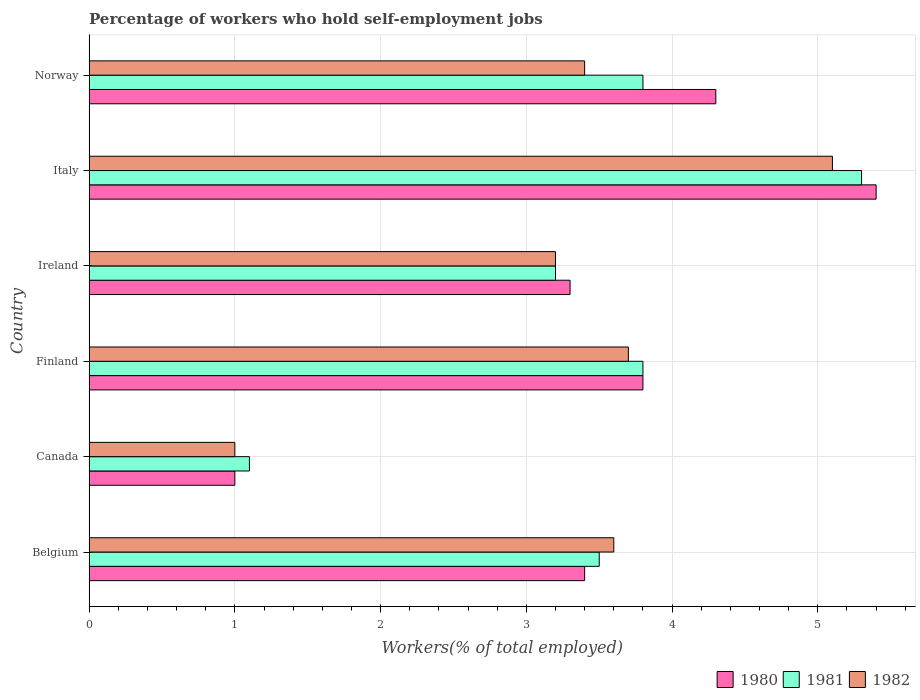How many groups of bars are there?
Keep it short and to the point. 6. Are the number of bars on each tick of the Y-axis equal?
Offer a terse response. Yes. How many bars are there on the 5th tick from the top?
Ensure brevity in your answer.  3. How many bars are there on the 1st tick from the bottom?
Make the answer very short. 3. In how many cases, is the number of bars for a given country not equal to the number of legend labels?
Keep it short and to the point. 0. What is the percentage of self-employed workers in 1982 in Ireland?
Provide a short and direct response. 3.2. Across all countries, what is the maximum percentage of self-employed workers in 1982?
Keep it short and to the point. 5.1. Across all countries, what is the minimum percentage of self-employed workers in 1980?
Your answer should be compact. 1. In which country was the percentage of self-employed workers in 1981 maximum?
Provide a short and direct response. Italy. In which country was the percentage of self-employed workers in 1980 minimum?
Ensure brevity in your answer.  Canada. What is the total percentage of self-employed workers in 1982 in the graph?
Your answer should be compact. 20. What is the difference between the percentage of self-employed workers in 1980 in Finland and that in Norway?
Provide a short and direct response. -0.5. What is the difference between the percentage of self-employed workers in 1982 in Norway and the percentage of self-employed workers in 1980 in Finland?
Give a very brief answer. -0.4. What is the average percentage of self-employed workers in 1981 per country?
Offer a very short reply. 3.45. What is the difference between the percentage of self-employed workers in 1982 and percentage of self-employed workers in 1980 in Norway?
Ensure brevity in your answer.  -0.9. What is the ratio of the percentage of self-employed workers in 1980 in Finland to that in Italy?
Ensure brevity in your answer.  0.7. What is the difference between the highest and the second highest percentage of self-employed workers in 1981?
Provide a short and direct response. 1.5. What is the difference between the highest and the lowest percentage of self-employed workers in 1980?
Your answer should be very brief. 4.4. Is the sum of the percentage of self-employed workers in 1982 in Canada and Ireland greater than the maximum percentage of self-employed workers in 1980 across all countries?
Your answer should be compact. No. What does the 1st bar from the top in Belgium represents?
Provide a succinct answer. 1982. What does the 1st bar from the bottom in Italy represents?
Your response must be concise. 1980. Is it the case that in every country, the sum of the percentage of self-employed workers in 1980 and percentage of self-employed workers in 1982 is greater than the percentage of self-employed workers in 1981?
Offer a terse response. Yes. Are all the bars in the graph horizontal?
Keep it short and to the point. Yes. How many countries are there in the graph?
Make the answer very short. 6. Are the values on the major ticks of X-axis written in scientific E-notation?
Provide a short and direct response. No. How many legend labels are there?
Keep it short and to the point. 3. What is the title of the graph?
Your answer should be compact. Percentage of workers who hold self-employment jobs. Does "1976" appear as one of the legend labels in the graph?
Make the answer very short. No. What is the label or title of the X-axis?
Offer a terse response. Workers(% of total employed). What is the label or title of the Y-axis?
Make the answer very short. Country. What is the Workers(% of total employed) of 1980 in Belgium?
Give a very brief answer. 3.4. What is the Workers(% of total employed) of 1981 in Belgium?
Your response must be concise. 3.5. What is the Workers(% of total employed) of 1982 in Belgium?
Your answer should be very brief. 3.6. What is the Workers(% of total employed) in 1981 in Canada?
Provide a succinct answer. 1.1. What is the Workers(% of total employed) in 1980 in Finland?
Make the answer very short. 3.8. What is the Workers(% of total employed) of 1981 in Finland?
Offer a very short reply. 3.8. What is the Workers(% of total employed) of 1982 in Finland?
Make the answer very short. 3.7. What is the Workers(% of total employed) in 1980 in Ireland?
Give a very brief answer. 3.3. What is the Workers(% of total employed) in 1981 in Ireland?
Your response must be concise. 3.2. What is the Workers(% of total employed) in 1982 in Ireland?
Ensure brevity in your answer.  3.2. What is the Workers(% of total employed) in 1980 in Italy?
Give a very brief answer. 5.4. What is the Workers(% of total employed) of 1981 in Italy?
Make the answer very short. 5.3. What is the Workers(% of total employed) in 1982 in Italy?
Your answer should be compact. 5.1. What is the Workers(% of total employed) in 1980 in Norway?
Give a very brief answer. 4.3. What is the Workers(% of total employed) of 1981 in Norway?
Your response must be concise. 3.8. What is the Workers(% of total employed) of 1982 in Norway?
Ensure brevity in your answer.  3.4. Across all countries, what is the maximum Workers(% of total employed) in 1980?
Offer a very short reply. 5.4. Across all countries, what is the maximum Workers(% of total employed) in 1981?
Your answer should be compact. 5.3. Across all countries, what is the maximum Workers(% of total employed) in 1982?
Keep it short and to the point. 5.1. Across all countries, what is the minimum Workers(% of total employed) of 1981?
Offer a very short reply. 1.1. What is the total Workers(% of total employed) of 1980 in the graph?
Your response must be concise. 21.2. What is the total Workers(% of total employed) in 1981 in the graph?
Offer a very short reply. 20.7. What is the difference between the Workers(% of total employed) of 1980 in Belgium and that in Canada?
Provide a short and direct response. 2.4. What is the difference between the Workers(% of total employed) of 1982 in Belgium and that in Canada?
Give a very brief answer. 2.6. What is the difference between the Workers(% of total employed) in 1980 in Belgium and that in Ireland?
Offer a very short reply. 0.1. What is the difference between the Workers(% of total employed) in 1981 in Belgium and that in Ireland?
Ensure brevity in your answer.  0.3. What is the difference between the Workers(% of total employed) in 1982 in Belgium and that in Ireland?
Ensure brevity in your answer.  0.4. What is the difference between the Workers(% of total employed) of 1981 in Belgium and that in Italy?
Keep it short and to the point. -1.8. What is the difference between the Workers(% of total employed) in 1982 in Belgium and that in Italy?
Your response must be concise. -1.5. What is the difference between the Workers(% of total employed) in 1980 in Belgium and that in Norway?
Keep it short and to the point. -0.9. What is the difference between the Workers(% of total employed) of 1980 in Canada and that in Finland?
Make the answer very short. -2.8. What is the difference between the Workers(% of total employed) of 1981 in Canada and that in Finland?
Your response must be concise. -2.7. What is the difference between the Workers(% of total employed) of 1980 in Canada and that in Ireland?
Give a very brief answer. -2.3. What is the difference between the Workers(% of total employed) of 1982 in Canada and that in Ireland?
Offer a terse response. -2.2. What is the difference between the Workers(% of total employed) in 1980 in Canada and that in Italy?
Your response must be concise. -4.4. What is the difference between the Workers(% of total employed) of 1981 in Canada and that in Italy?
Keep it short and to the point. -4.2. What is the difference between the Workers(% of total employed) in 1981 in Canada and that in Norway?
Offer a terse response. -2.7. What is the difference between the Workers(% of total employed) of 1982 in Canada and that in Norway?
Provide a short and direct response. -2.4. What is the difference between the Workers(% of total employed) of 1980 in Finland and that in Italy?
Provide a short and direct response. -1.6. What is the difference between the Workers(% of total employed) of 1981 in Finland and that in Italy?
Offer a terse response. -1.5. What is the difference between the Workers(% of total employed) of 1982 in Finland and that in Italy?
Your answer should be compact. -1.4. What is the difference between the Workers(% of total employed) of 1981 in Ireland and that in Norway?
Your response must be concise. -0.6. What is the difference between the Workers(% of total employed) of 1981 in Italy and that in Norway?
Provide a short and direct response. 1.5. What is the difference between the Workers(% of total employed) of 1980 in Belgium and the Workers(% of total employed) of 1981 in Finland?
Your answer should be very brief. -0.4. What is the difference between the Workers(% of total employed) in 1981 in Belgium and the Workers(% of total employed) in 1982 in Ireland?
Offer a terse response. 0.3. What is the difference between the Workers(% of total employed) of 1981 in Belgium and the Workers(% of total employed) of 1982 in Italy?
Provide a succinct answer. -1.6. What is the difference between the Workers(% of total employed) in 1980 in Belgium and the Workers(% of total employed) in 1982 in Norway?
Offer a very short reply. 0. What is the difference between the Workers(% of total employed) in 1981 in Belgium and the Workers(% of total employed) in 1982 in Norway?
Provide a short and direct response. 0.1. What is the difference between the Workers(% of total employed) in 1981 in Canada and the Workers(% of total employed) in 1982 in Ireland?
Keep it short and to the point. -2.1. What is the difference between the Workers(% of total employed) of 1980 in Canada and the Workers(% of total employed) of 1981 in Italy?
Your response must be concise. -4.3. What is the difference between the Workers(% of total employed) of 1980 in Canada and the Workers(% of total employed) of 1982 in Italy?
Make the answer very short. -4.1. What is the difference between the Workers(% of total employed) in 1981 in Canada and the Workers(% of total employed) in 1982 in Italy?
Keep it short and to the point. -4. What is the difference between the Workers(% of total employed) of 1980 in Canada and the Workers(% of total employed) of 1982 in Norway?
Your response must be concise. -2.4. What is the difference between the Workers(% of total employed) in 1981 in Canada and the Workers(% of total employed) in 1982 in Norway?
Offer a very short reply. -2.3. What is the difference between the Workers(% of total employed) of 1981 in Finland and the Workers(% of total employed) of 1982 in Ireland?
Offer a terse response. 0.6. What is the difference between the Workers(% of total employed) of 1980 in Finland and the Workers(% of total employed) of 1982 in Italy?
Make the answer very short. -1.3. What is the difference between the Workers(% of total employed) of 1980 in Finland and the Workers(% of total employed) of 1982 in Norway?
Your answer should be very brief. 0.4. What is the difference between the Workers(% of total employed) of 1980 in Ireland and the Workers(% of total employed) of 1981 in Italy?
Provide a succinct answer. -2. What is the difference between the Workers(% of total employed) of 1980 in Ireland and the Workers(% of total employed) of 1982 in Italy?
Offer a very short reply. -1.8. What is the difference between the Workers(% of total employed) in 1980 in Italy and the Workers(% of total employed) in 1981 in Norway?
Provide a short and direct response. 1.6. What is the difference between the Workers(% of total employed) of 1980 in Italy and the Workers(% of total employed) of 1982 in Norway?
Give a very brief answer. 2. What is the difference between the Workers(% of total employed) of 1981 in Italy and the Workers(% of total employed) of 1982 in Norway?
Your response must be concise. 1.9. What is the average Workers(% of total employed) of 1980 per country?
Your answer should be very brief. 3.53. What is the average Workers(% of total employed) of 1981 per country?
Your response must be concise. 3.45. What is the difference between the Workers(% of total employed) in 1980 and Workers(% of total employed) in 1981 in Belgium?
Provide a succinct answer. -0.1. What is the difference between the Workers(% of total employed) in 1980 and Workers(% of total employed) in 1982 in Belgium?
Your answer should be compact. -0.2. What is the difference between the Workers(% of total employed) in 1980 and Workers(% of total employed) in 1981 in Canada?
Your response must be concise. -0.1. What is the difference between the Workers(% of total employed) of 1980 and Workers(% of total employed) of 1982 in Canada?
Your answer should be compact. 0. What is the difference between the Workers(% of total employed) of 1981 and Workers(% of total employed) of 1982 in Canada?
Make the answer very short. 0.1. What is the difference between the Workers(% of total employed) in 1980 and Workers(% of total employed) in 1981 in Finland?
Your response must be concise. 0. What is the difference between the Workers(% of total employed) of 1980 and Workers(% of total employed) of 1982 in Finland?
Make the answer very short. 0.1. What is the difference between the Workers(% of total employed) of 1981 and Workers(% of total employed) of 1982 in Finland?
Make the answer very short. 0.1. What is the difference between the Workers(% of total employed) in 1980 and Workers(% of total employed) in 1981 in Ireland?
Provide a succinct answer. 0.1. What is the difference between the Workers(% of total employed) in 1980 and Workers(% of total employed) in 1982 in Ireland?
Make the answer very short. 0.1. What is the difference between the Workers(% of total employed) in 1980 and Workers(% of total employed) in 1981 in Italy?
Offer a very short reply. 0.1. What is the difference between the Workers(% of total employed) in 1980 and Workers(% of total employed) in 1982 in Italy?
Ensure brevity in your answer.  0.3. What is the difference between the Workers(% of total employed) of 1981 and Workers(% of total employed) of 1982 in Italy?
Ensure brevity in your answer.  0.2. What is the difference between the Workers(% of total employed) in 1980 and Workers(% of total employed) in 1981 in Norway?
Offer a very short reply. 0.5. What is the difference between the Workers(% of total employed) in 1980 and Workers(% of total employed) in 1982 in Norway?
Your answer should be compact. 0.9. What is the ratio of the Workers(% of total employed) in 1980 in Belgium to that in Canada?
Your answer should be very brief. 3.4. What is the ratio of the Workers(% of total employed) of 1981 in Belgium to that in Canada?
Your response must be concise. 3.18. What is the ratio of the Workers(% of total employed) of 1980 in Belgium to that in Finland?
Your answer should be compact. 0.89. What is the ratio of the Workers(% of total employed) in 1981 in Belgium to that in Finland?
Provide a succinct answer. 0.92. What is the ratio of the Workers(% of total employed) in 1982 in Belgium to that in Finland?
Make the answer very short. 0.97. What is the ratio of the Workers(% of total employed) of 1980 in Belgium to that in Ireland?
Ensure brevity in your answer.  1.03. What is the ratio of the Workers(% of total employed) in 1981 in Belgium to that in Ireland?
Your response must be concise. 1.09. What is the ratio of the Workers(% of total employed) in 1982 in Belgium to that in Ireland?
Your answer should be very brief. 1.12. What is the ratio of the Workers(% of total employed) in 1980 in Belgium to that in Italy?
Your answer should be compact. 0.63. What is the ratio of the Workers(% of total employed) in 1981 in Belgium to that in Italy?
Make the answer very short. 0.66. What is the ratio of the Workers(% of total employed) in 1982 in Belgium to that in Italy?
Ensure brevity in your answer.  0.71. What is the ratio of the Workers(% of total employed) in 1980 in Belgium to that in Norway?
Offer a terse response. 0.79. What is the ratio of the Workers(% of total employed) in 1981 in Belgium to that in Norway?
Give a very brief answer. 0.92. What is the ratio of the Workers(% of total employed) in 1982 in Belgium to that in Norway?
Keep it short and to the point. 1.06. What is the ratio of the Workers(% of total employed) of 1980 in Canada to that in Finland?
Make the answer very short. 0.26. What is the ratio of the Workers(% of total employed) in 1981 in Canada to that in Finland?
Provide a short and direct response. 0.29. What is the ratio of the Workers(% of total employed) in 1982 in Canada to that in Finland?
Offer a terse response. 0.27. What is the ratio of the Workers(% of total employed) of 1980 in Canada to that in Ireland?
Your response must be concise. 0.3. What is the ratio of the Workers(% of total employed) of 1981 in Canada to that in Ireland?
Offer a terse response. 0.34. What is the ratio of the Workers(% of total employed) in 1982 in Canada to that in Ireland?
Ensure brevity in your answer.  0.31. What is the ratio of the Workers(% of total employed) in 1980 in Canada to that in Italy?
Your answer should be very brief. 0.19. What is the ratio of the Workers(% of total employed) in 1981 in Canada to that in Italy?
Ensure brevity in your answer.  0.21. What is the ratio of the Workers(% of total employed) of 1982 in Canada to that in Italy?
Give a very brief answer. 0.2. What is the ratio of the Workers(% of total employed) of 1980 in Canada to that in Norway?
Your response must be concise. 0.23. What is the ratio of the Workers(% of total employed) in 1981 in Canada to that in Norway?
Give a very brief answer. 0.29. What is the ratio of the Workers(% of total employed) in 1982 in Canada to that in Norway?
Provide a short and direct response. 0.29. What is the ratio of the Workers(% of total employed) in 1980 in Finland to that in Ireland?
Offer a terse response. 1.15. What is the ratio of the Workers(% of total employed) of 1981 in Finland to that in Ireland?
Your response must be concise. 1.19. What is the ratio of the Workers(% of total employed) of 1982 in Finland to that in Ireland?
Provide a short and direct response. 1.16. What is the ratio of the Workers(% of total employed) in 1980 in Finland to that in Italy?
Make the answer very short. 0.7. What is the ratio of the Workers(% of total employed) in 1981 in Finland to that in Italy?
Ensure brevity in your answer.  0.72. What is the ratio of the Workers(% of total employed) of 1982 in Finland to that in Italy?
Offer a terse response. 0.73. What is the ratio of the Workers(% of total employed) of 1980 in Finland to that in Norway?
Provide a short and direct response. 0.88. What is the ratio of the Workers(% of total employed) in 1981 in Finland to that in Norway?
Provide a short and direct response. 1. What is the ratio of the Workers(% of total employed) in 1982 in Finland to that in Norway?
Your answer should be very brief. 1.09. What is the ratio of the Workers(% of total employed) in 1980 in Ireland to that in Italy?
Provide a short and direct response. 0.61. What is the ratio of the Workers(% of total employed) of 1981 in Ireland to that in Italy?
Your response must be concise. 0.6. What is the ratio of the Workers(% of total employed) in 1982 in Ireland to that in Italy?
Your response must be concise. 0.63. What is the ratio of the Workers(% of total employed) in 1980 in Ireland to that in Norway?
Make the answer very short. 0.77. What is the ratio of the Workers(% of total employed) in 1981 in Ireland to that in Norway?
Your answer should be very brief. 0.84. What is the ratio of the Workers(% of total employed) in 1982 in Ireland to that in Norway?
Provide a short and direct response. 0.94. What is the ratio of the Workers(% of total employed) in 1980 in Italy to that in Norway?
Offer a terse response. 1.26. What is the ratio of the Workers(% of total employed) of 1981 in Italy to that in Norway?
Ensure brevity in your answer.  1.39. What is the difference between the highest and the second highest Workers(% of total employed) in 1981?
Keep it short and to the point. 1.5. What is the difference between the highest and the second highest Workers(% of total employed) in 1982?
Your answer should be compact. 1.4. What is the difference between the highest and the lowest Workers(% of total employed) of 1980?
Give a very brief answer. 4.4. What is the difference between the highest and the lowest Workers(% of total employed) in 1981?
Keep it short and to the point. 4.2. 